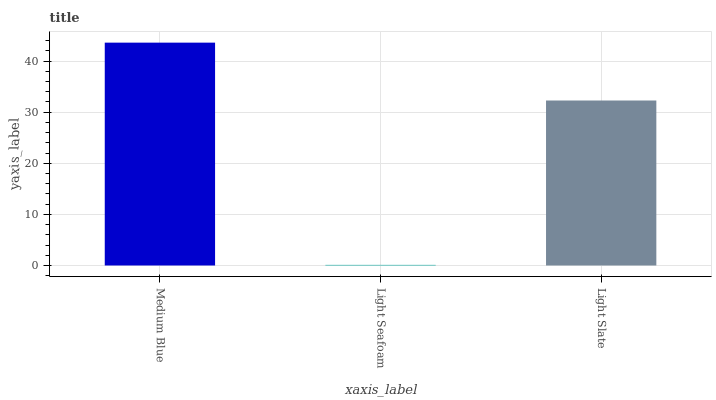Is Light Seafoam the minimum?
Answer yes or no. Yes. Is Medium Blue the maximum?
Answer yes or no. Yes. Is Light Slate the minimum?
Answer yes or no. No. Is Light Slate the maximum?
Answer yes or no. No. Is Light Slate greater than Light Seafoam?
Answer yes or no. Yes. Is Light Seafoam less than Light Slate?
Answer yes or no. Yes. Is Light Seafoam greater than Light Slate?
Answer yes or no. No. Is Light Slate less than Light Seafoam?
Answer yes or no. No. Is Light Slate the high median?
Answer yes or no. Yes. Is Light Slate the low median?
Answer yes or no. Yes. Is Light Seafoam the high median?
Answer yes or no. No. Is Medium Blue the low median?
Answer yes or no. No. 